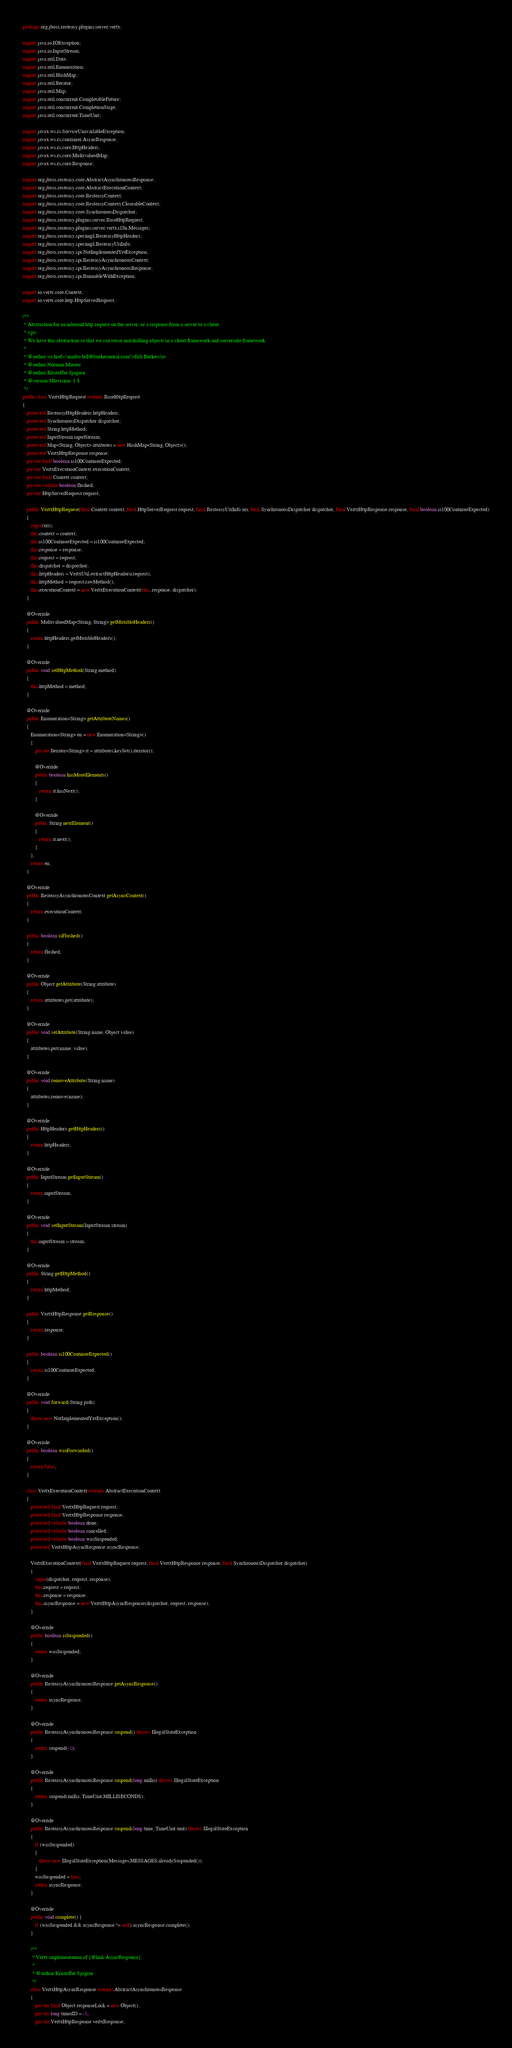<code> <loc_0><loc_0><loc_500><loc_500><_Java_>package org.jboss.resteasy.plugins.server.vertx;

import java.io.IOException;
import java.io.InputStream;
import java.util.Date;
import java.util.Enumeration;
import java.util.HashMap;
import java.util.Iterator;
import java.util.Map;
import java.util.concurrent.CompletableFuture;
import java.util.concurrent.CompletionStage;
import java.util.concurrent.TimeUnit;

import javax.ws.rs.ServiceUnavailableException;
import javax.ws.rs.container.AsyncResponse;
import javax.ws.rs.core.HttpHeaders;
import javax.ws.rs.core.MultivaluedMap;
import javax.ws.rs.core.Response;

import org.jboss.resteasy.core.AbstractAsynchronousResponse;
import org.jboss.resteasy.core.AbstractExecutionContext;
import org.jboss.resteasy.core.ResteasyContext;
import org.jboss.resteasy.core.ResteasyContext.CloseableContext;
import org.jboss.resteasy.core.SynchronousDispatcher;
import org.jboss.resteasy.plugins.server.BaseHttpRequest;
import org.jboss.resteasy.plugins.server.vertx.i18n.Messages;
import org.jboss.resteasy.specimpl.ResteasyHttpHeaders;
import org.jboss.resteasy.specimpl.ResteasyUriInfo;
import org.jboss.resteasy.spi.NotImplementedYetException;
import org.jboss.resteasy.spi.ResteasyAsynchronousContext;
import org.jboss.resteasy.spi.ResteasyAsynchronousResponse;
import org.jboss.resteasy.spi.RunnableWithException;

import io.vertx.core.Context;
import io.vertx.core.http.HttpServerRequest;

/**
 * Abstraction for an inbound http request on the server, or a response from a server to a client
 * <p>
 * We have this abstraction so that we can reuse marshalling objects in a client framework and serverside framework
 *
 * @author <a href="mailto:bill@burkecentral.com">Bill Burke</a>
 * @author Norman Maurer
 * @author Kristoffer Sjogren
 * @version $Revision: 1 $
 */
public class VertxHttpRequest extends BaseHttpRequest
{
   protected ResteasyHttpHeaders httpHeaders;
   protected SynchronousDispatcher dispatcher;
   protected String httpMethod;
   protected InputStream inputStream;
   protected Map<String, Object> attributes = new HashMap<String, Object>();
   protected VertxHttpResponse response;
   private final boolean is100ContinueExpected;
   private VertxExecutionContext executionContext;
   private final Context context;
   private volatile boolean flushed;
   private HttpServerRequest request;

   public VertxHttpRequest(final Context context, final HttpServerRequest request, final ResteasyUriInfo uri, final SynchronousDispatcher dispatcher, final VertxHttpResponse response, final boolean is100ContinueExpected)
   {
      super(uri);
      this.context = context;
      this.is100ContinueExpected = is100ContinueExpected;
      this.response = response;
      this.request = request;
      this.dispatcher = dispatcher;
      this.httpHeaders = VertxUtil.extractHttpHeaders(request);
      this.httpMethod = request.rawMethod();
      this.executionContext = new VertxExecutionContext(this, response, dispatcher);
   }

   @Override
   public MultivaluedMap<String, String> getMutableHeaders()
   {
      return httpHeaders.getMutableHeaders();
   }

   @Override
   public void setHttpMethod(String method)
   {
      this.httpMethod = method;
   }

   @Override
   public Enumeration<String> getAttributeNames()
   {
      Enumeration<String> en = new Enumeration<String>()
      {
         private Iterator<String> it = attributes.keySet().iterator();

         @Override
         public boolean hasMoreElements()
         {
            return it.hasNext();
         }

         @Override
         public String nextElement()
         {
            return it.next();
         }
      };
      return en;
   }

   @Override
   public ResteasyAsynchronousContext getAsyncContext()
   {
      return executionContext;
   }

   public boolean isFlushed()
   {
      return flushed;
   }

   @Override
   public Object getAttribute(String attribute)
   {
      return attributes.get(attribute);
   }

   @Override
   public void setAttribute(String name, Object value)
   {
      attributes.put(name, value);
   }

   @Override
   public void removeAttribute(String name)
   {
      attributes.remove(name);
   }

   @Override
   public HttpHeaders getHttpHeaders()
   {
      return httpHeaders;
   }

   @Override
   public InputStream getInputStream()
   {
      return inputStream;
   }

   @Override
   public void setInputStream(InputStream stream)
   {
      this.inputStream = stream;
   }

   @Override
   public String getHttpMethod()
   {
      return httpMethod;
   }

   public VertxHttpResponse getResponse()
   {
      return response;
   }

   public boolean is100ContinueExpected()
   {
      return is100ContinueExpected;
   }

   @Override
   public void forward(String path)
   {
      throw new NotImplementedYetException();
   }

   @Override
   public boolean wasForwarded()
   {
      return false;
   }

   class VertxExecutionContext extends AbstractExecutionContext
   {
      protected final VertxHttpRequest request;
      protected final VertxHttpResponse response;
      protected volatile boolean done;
      protected volatile boolean cancelled;
      protected volatile boolean wasSuspended;
      protected VertxHttpAsyncResponse asyncResponse;

      VertxExecutionContext(final VertxHttpRequest request, final VertxHttpResponse response, final SynchronousDispatcher dispatcher)
      {
         super(dispatcher, request, response);
         this.request = request;
         this.response = response;
         this.asyncResponse = new VertxHttpAsyncResponse(dispatcher, request, response);
      }

      @Override
      public boolean isSuspended()
      {
         return wasSuspended;
      }

      @Override
      public ResteasyAsynchronousResponse getAsyncResponse()
      {
         return asyncResponse;
      }

      @Override
      public ResteasyAsynchronousResponse suspend() throws IllegalStateException
      {
         return suspend(-1);
      }

      @Override
      public ResteasyAsynchronousResponse suspend(long millis) throws IllegalStateException
      {
         return suspend(millis, TimeUnit.MILLISECONDS);
      }

      @Override
      public ResteasyAsynchronousResponse suspend(long time, TimeUnit unit) throws IllegalStateException
      {
         if (wasSuspended)
         {
            throw new IllegalStateException(Messages.MESSAGES.alreadySuspended());
         }
         wasSuspended = true;
         return asyncResponse;
      }

      @Override
      public void complete() {
         if (wasSuspended && asyncResponse != null) asyncResponse.complete();
      }

      /**
       * Vertx implementation of {@link AsyncResponse}.
       *
       * @author Kristoffer Sjogren
       */
      class VertxHttpAsyncResponse extends AbstractAsynchronousResponse
      {
         private final Object responseLock = new Object();
         private long timerID = -1;
         private VertxHttpResponse vertxResponse;
</code> 